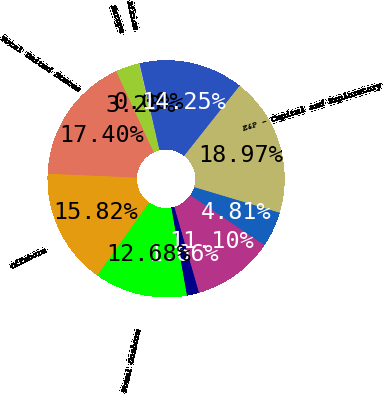Convert chart. <chart><loc_0><loc_0><loc_500><loc_500><pie_chart><fcel>Bakken<fcel>Other Onshore<fcel>Total Onshore<fcel>Offshore<fcel>Total United States<fcel>Europe<fcel>Africa<fcel>Asia and other<fcel>E&P - Capital and Exploratory<fcel>United States<nl><fcel>11.1%<fcel>1.66%<fcel>12.68%<fcel>15.82%<fcel>17.4%<fcel>3.23%<fcel>0.08%<fcel>14.25%<fcel>18.97%<fcel>4.81%<nl></chart> 